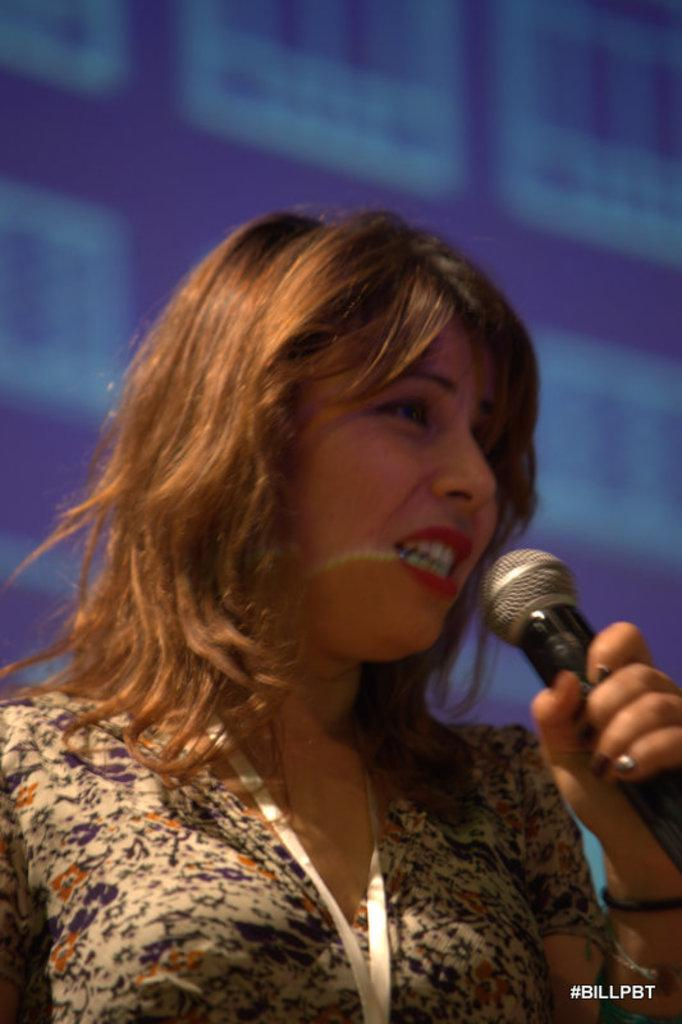Who is the main subject in the image? There is a lady in the image. What is the lady wearing? The lady is wearing a floral dress. What is the lady doing in the image? The lady is standing and holding a microphone in her hand, and she is speaking. What can be seen in the background of the image? There is a blue color screen in the background of the image. Can you see any crayons being used by the lady in the image? There are no crayons visible in the image, and the lady is not using any. Is there an ocean visible in the background of the image? No, there is no ocean present in the image; the background features a blue color screen. 